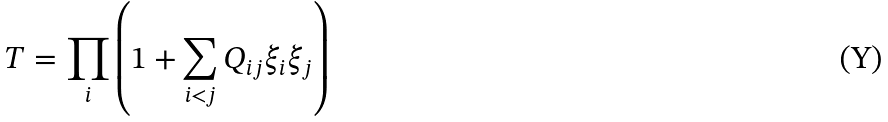<formula> <loc_0><loc_0><loc_500><loc_500>T = \prod _ { i } \left ( 1 + \sum _ { i < j } Q _ { i j } \xi _ { i } \xi _ { j } \right )</formula> 